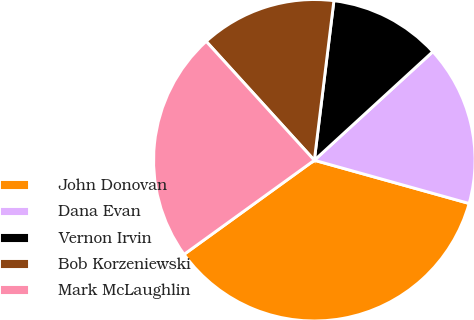Convert chart. <chart><loc_0><loc_0><loc_500><loc_500><pie_chart><fcel>John Donovan<fcel>Dana Evan<fcel>Vernon Irvin<fcel>Bob Korzeniewski<fcel>Mark McLaughlin<nl><fcel>35.71%<fcel>16.14%<fcel>11.25%<fcel>13.69%<fcel>23.21%<nl></chart> 